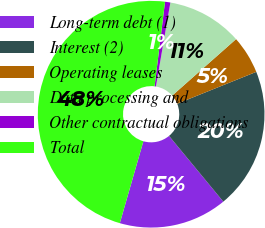Convert chart. <chart><loc_0><loc_0><loc_500><loc_500><pie_chart><fcel>Long-term debt (1)<fcel>Interest (2)<fcel>Operating leases<fcel>Data processing and<fcel>Other contractual obligations<fcel>Total<nl><fcel>15.44%<fcel>20.11%<fcel>5.43%<fcel>10.76%<fcel>0.76%<fcel>47.5%<nl></chart> 